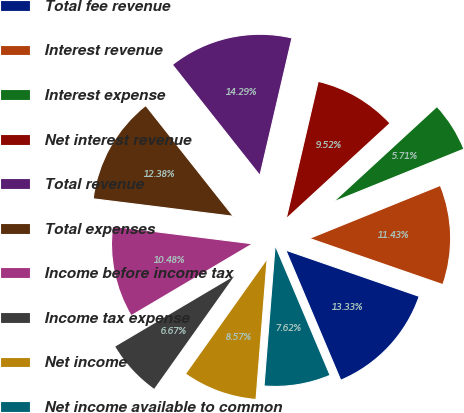<chart> <loc_0><loc_0><loc_500><loc_500><pie_chart><fcel>Total fee revenue<fcel>Interest revenue<fcel>Interest expense<fcel>Net interest revenue<fcel>Total revenue<fcel>Total expenses<fcel>Income before income tax<fcel>Income tax expense<fcel>Net income<fcel>Net income available to common<nl><fcel>13.33%<fcel>11.43%<fcel>5.71%<fcel>9.52%<fcel>14.29%<fcel>12.38%<fcel>10.48%<fcel>6.67%<fcel>8.57%<fcel>7.62%<nl></chart> 